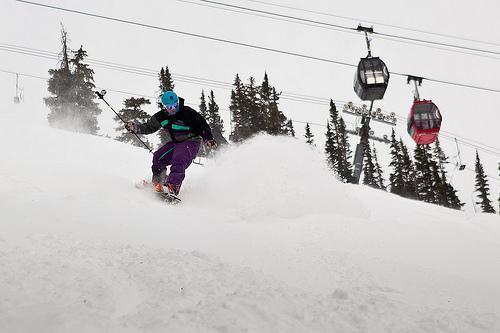How many people are there?
Give a very brief answer. 1. 